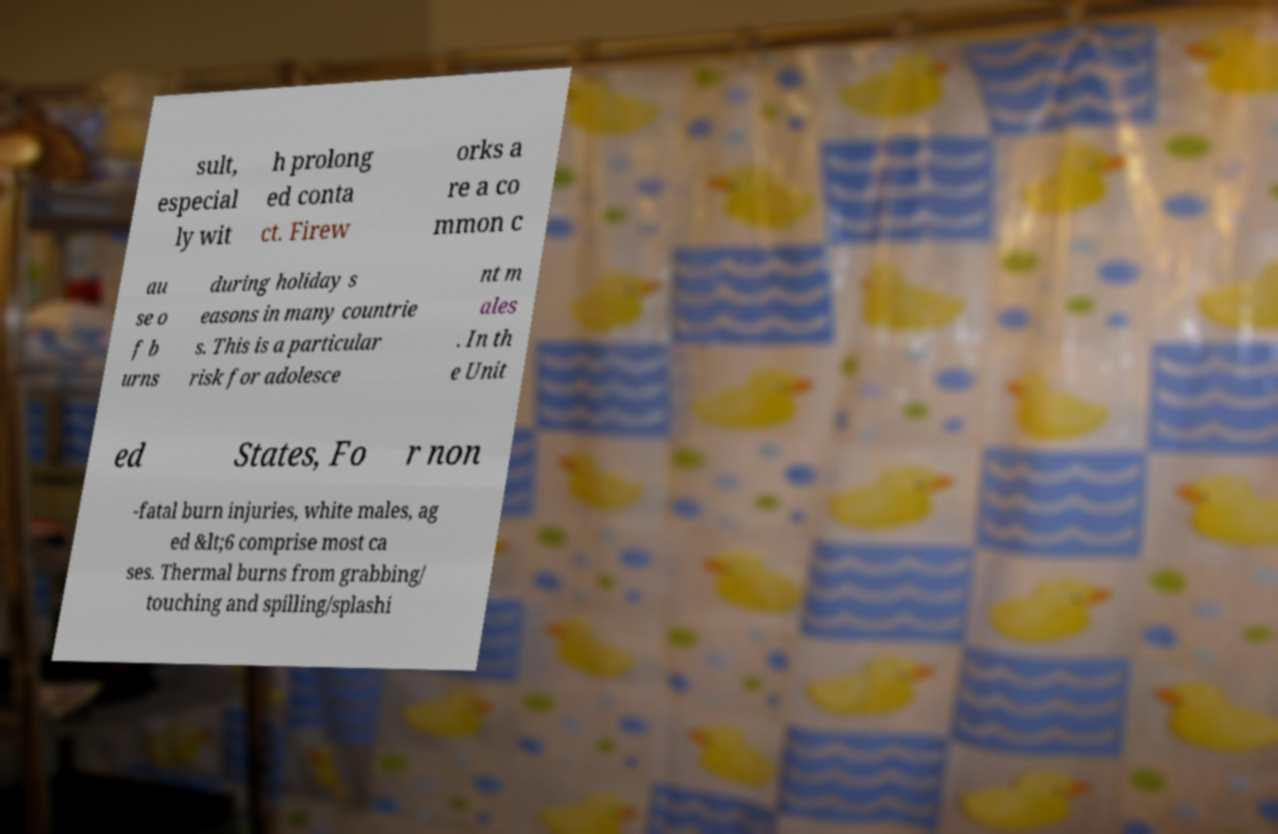I need the written content from this picture converted into text. Can you do that? sult, especial ly wit h prolong ed conta ct. Firew orks a re a co mmon c au se o f b urns during holiday s easons in many countrie s. This is a particular risk for adolesce nt m ales . In th e Unit ed States, Fo r non -fatal burn injuries, white males, ag ed &lt;6 comprise most ca ses. Thermal burns from grabbing/ touching and spilling/splashi 